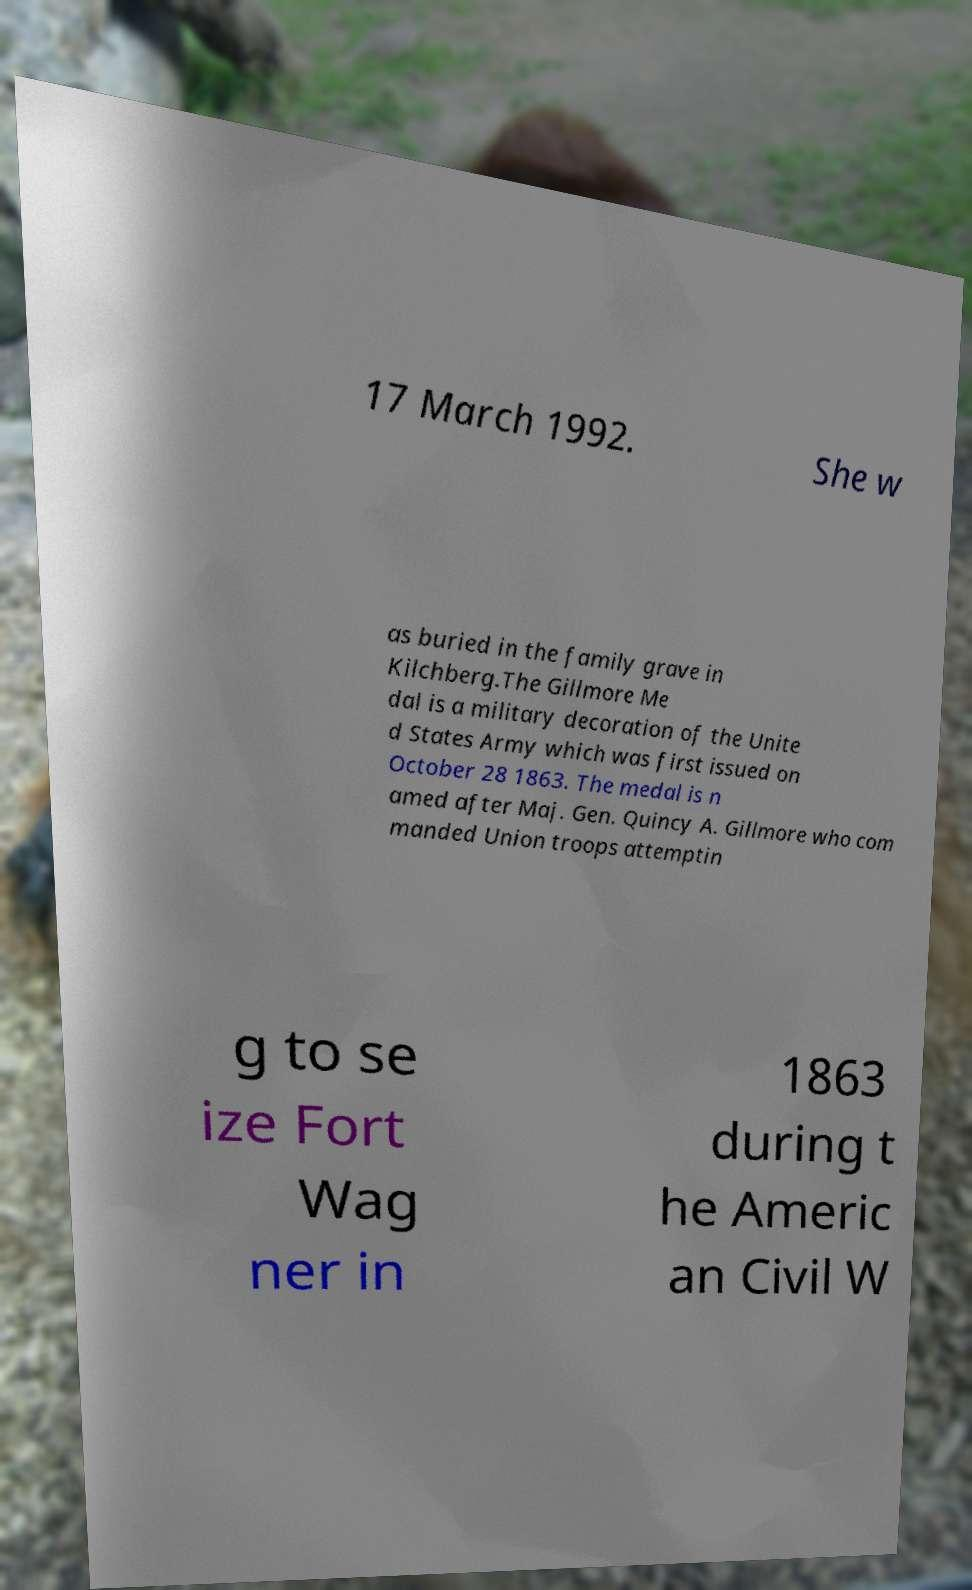Please identify and transcribe the text found in this image. 17 March 1992. She w as buried in the family grave in Kilchberg.The Gillmore Me dal is a military decoration of the Unite d States Army which was first issued on October 28 1863. The medal is n amed after Maj. Gen. Quincy A. Gillmore who com manded Union troops attemptin g to se ize Fort Wag ner in 1863 during t he Americ an Civil W 